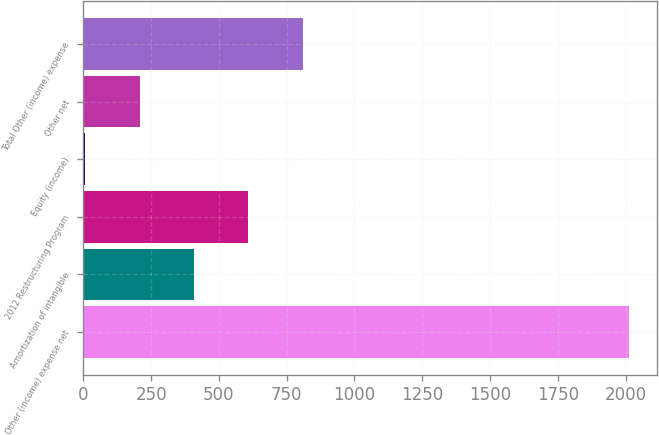Convert chart. <chart><loc_0><loc_0><loc_500><loc_500><bar_chart><fcel>Other (income) expense net<fcel>Amortization of intangible<fcel>2012 Restructuring Program<fcel>Equity (income)<fcel>Other net<fcel>Total Other (income) expense<nl><fcel>2014<fcel>408.4<fcel>609.1<fcel>7<fcel>207.7<fcel>809.8<nl></chart> 